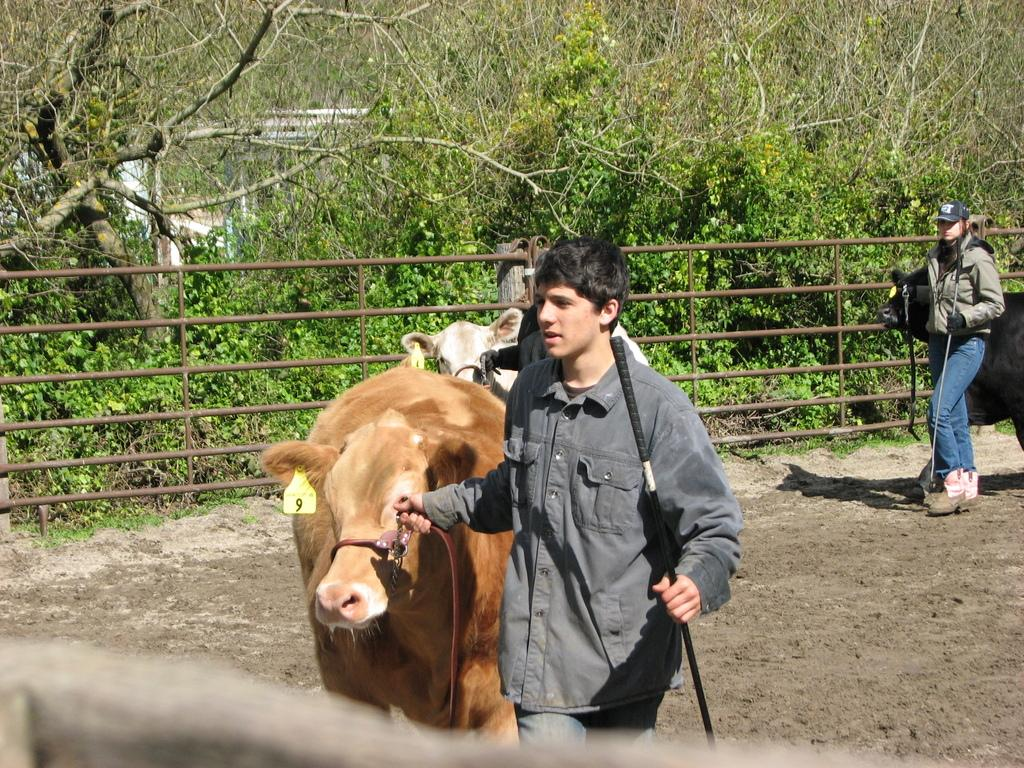How many people are in the image? There are three persons in the image. What are the persons holding in their hands? The persons are holding sticks in their hands. What other living beings can be seen in the image? There are animals visible in the image. What type of barrier is present in the image? There is a fence in the image. What can be seen in the background of the image? There are trees in the background of the image. Where is the playground located in the image? There is no playground present in the image. What type of knee injury can be seen on one of the persons in the image? There is no knee injury visible on any of the persons in the image. 